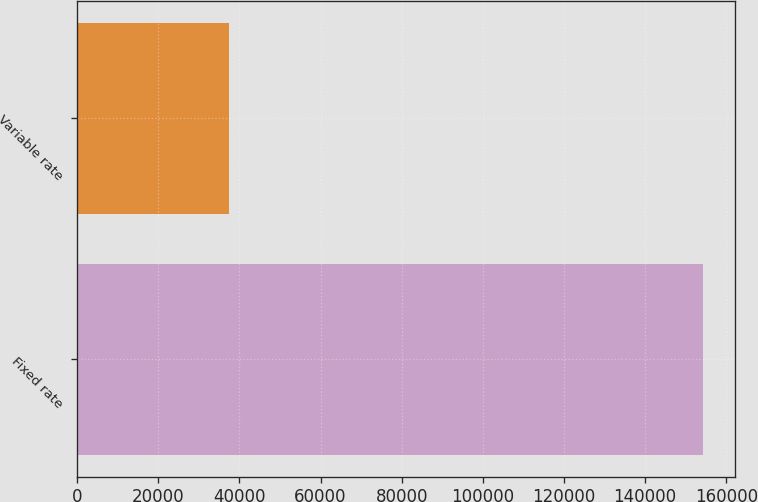<chart> <loc_0><loc_0><loc_500><loc_500><bar_chart><fcel>Fixed rate<fcel>Variable rate<nl><fcel>154368<fcel>37560<nl></chart> 